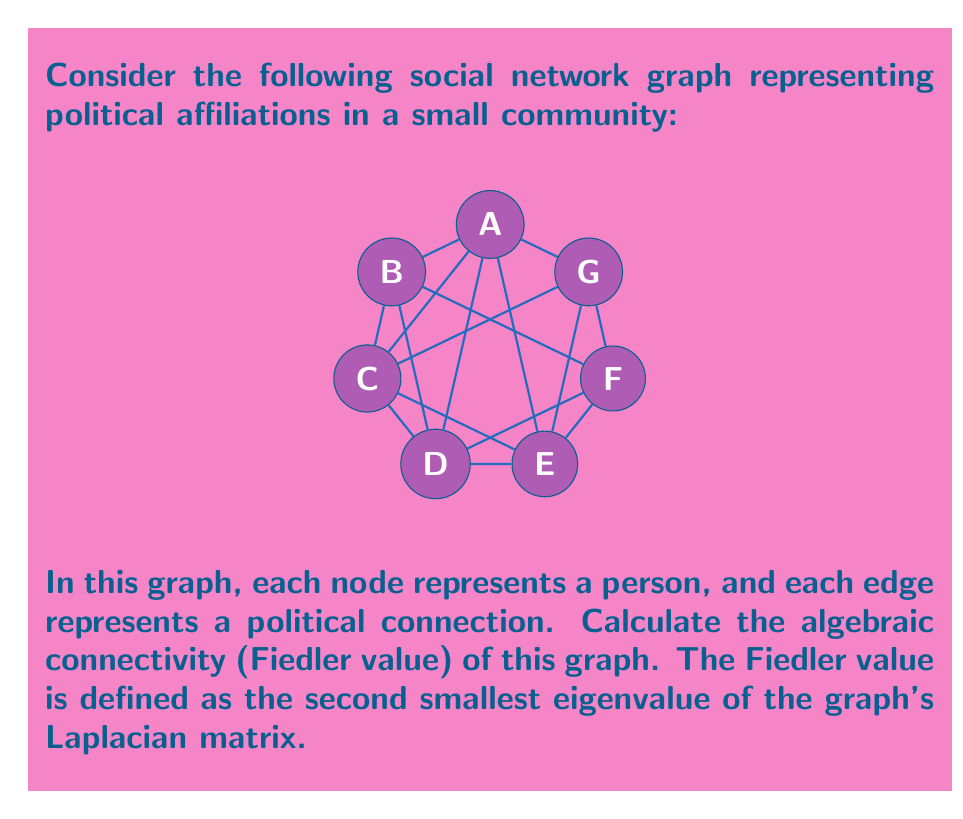Solve this math problem. To solve this problem, we'll follow these steps:

1) First, we need to construct the adjacency matrix $A$ of the graph.
2) Then, we'll calculate the degree matrix $D$.
3) We'll use these to compute the Laplacian matrix $L = D - A$.
4) Finally, we'll find the eigenvalues of $L$ and identify the second smallest one.

Step 1: Adjacency matrix $A$
$$A = \begin{bmatrix}
0 & 1 & 1 & 1 & 1 & 1 & 1 \\
1 & 0 & 1 & 1 & 0 & 1 & 1 \\
1 & 1 & 0 & 1 & 1 & 0 & 1 \\
1 & 1 & 1 & 0 & 1 & 1 & 0 \\
1 & 0 & 1 & 1 & 0 & 1 & 1 \\
1 & 1 & 0 & 1 & 1 & 0 & 1 \\
1 & 1 & 1 & 0 & 1 & 1 & 0
\end{bmatrix}$$

Step 2: Degree matrix $D$
The degree of each node is the sum of its row in $A$:
$$D = \text{diag}(6, 5, 5, 5, 5, 5, 5)$$

Step 3: Laplacian matrix $L = D - A$
$$L = \begin{bmatrix}
6 & -1 & -1 & -1 & -1 & -1 & -1 \\
-1 & 5 & -1 & -1 & 0 & -1 & -1 \\
-1 & -1 & 5 & -1 & -1 & 0 & -1 \\
-1 & -1 & -1 & 5 & -1 & -1 & 0 \\
-1 & 0 & -1 & -1 & 5 & -1 & -1 \\
-1 & -1 & 0 & -1 & -1 & 5 & -1 \\
-1 & -1 & -1 & 0 & -1 & -1 & 5
\end{bmatrix}$$

Step 4: Eigenvalues of $L$
Using a computer algebra system or numerical methods, we can find the eigenvalues of $L$:

$\lambda_1 = 0$
$\lambda_2 \approx 1.5858$
$\lambda_3 \approx 3.0000$
$\lambda_4 = \lambda_5 = 5$
$\lambda_6 \approx 6.4142$
$\lambda_7 = 7$

The Fiedler value is the second smallest eigenvalue, $\lambda_2 \approx 1.5858$.
Answer: $1.5858$ (rounded to 4 decimal places) 